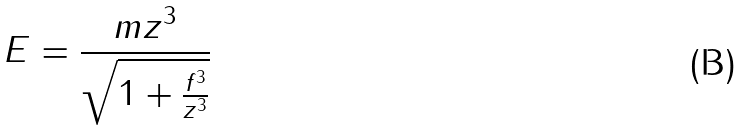Convert formula to latex. <formula><loc_0><loc_0><loc_500><loc_500>E = \frac { m z ^ { 3 } } { \sqrt { 1 + \frac { f ^ { 3 } } { z ^ { 3 } } } }</formula> 